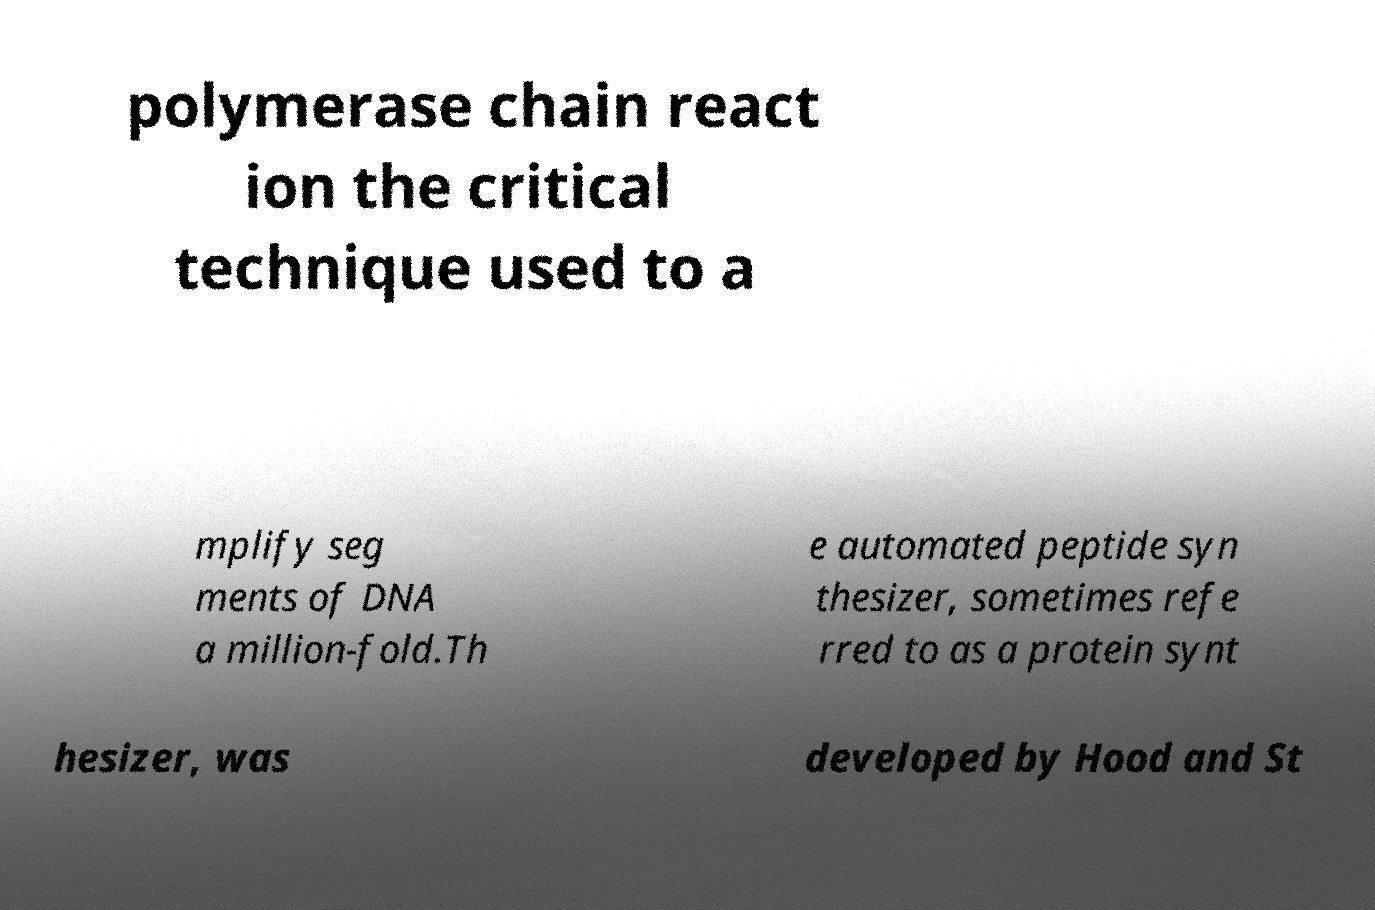Could you assist in decoding the text presented in this image and type it out clearly? polymerase chain react ion the critical technique used to a mplify seg ments of DNA a million-fold.Th e automated peptide syn thesizer, sometimes refe rred to as a protein synt hesizer, was developed by Hood and St 